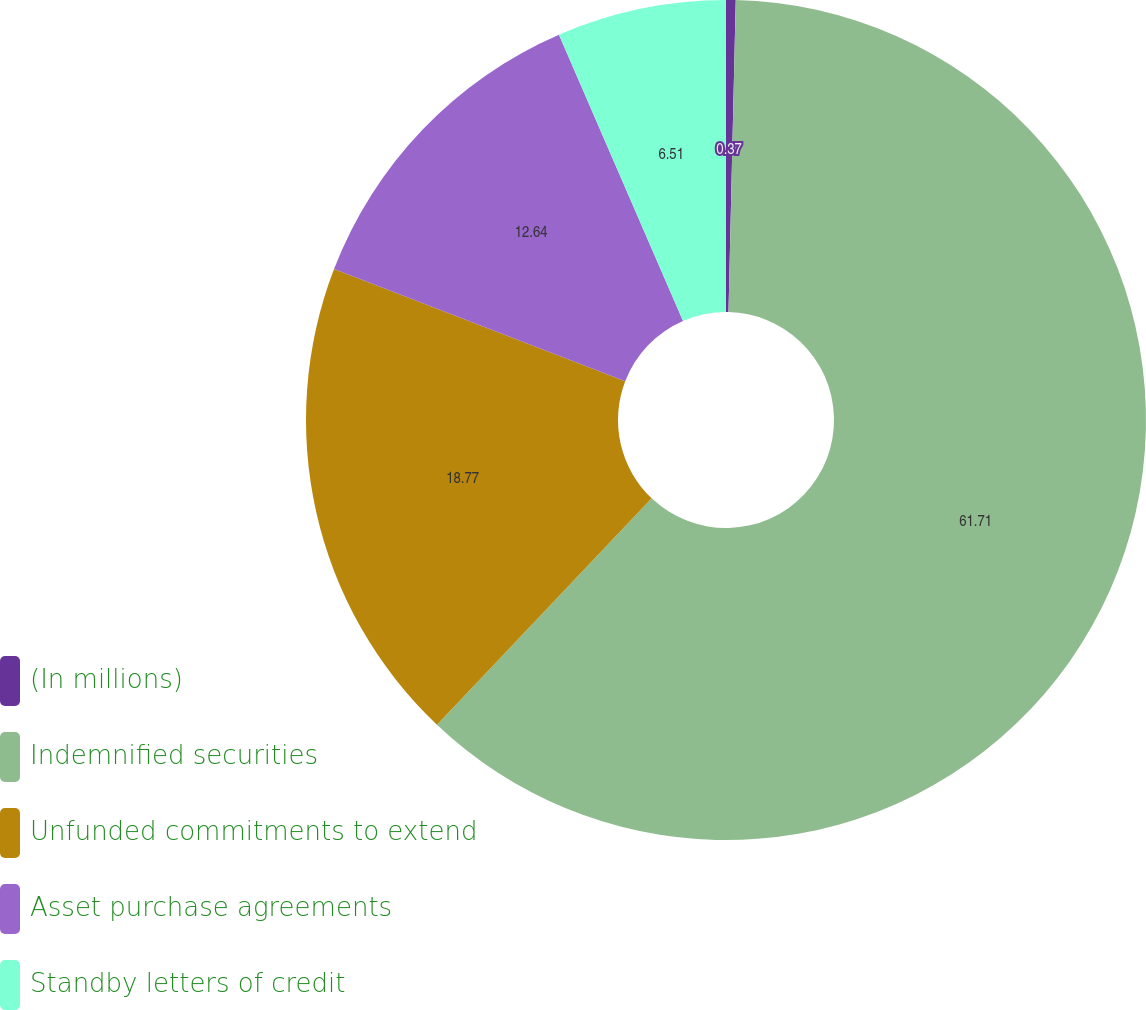Convert chart. <chart><loc_0><loc_0><loc_500><loc_500><pie_chart><fcel>(In millions)<fcel>Indemnified securities<fcel>Unfunded commitments to extend<fcel>Asset purchase agreements<fcel>Standby letters of credit<nl><fcel>0.37%<fcel>61.71%<fcel>18.77%<fcel>12.64%<fcel>6.51%<nl></chart> 